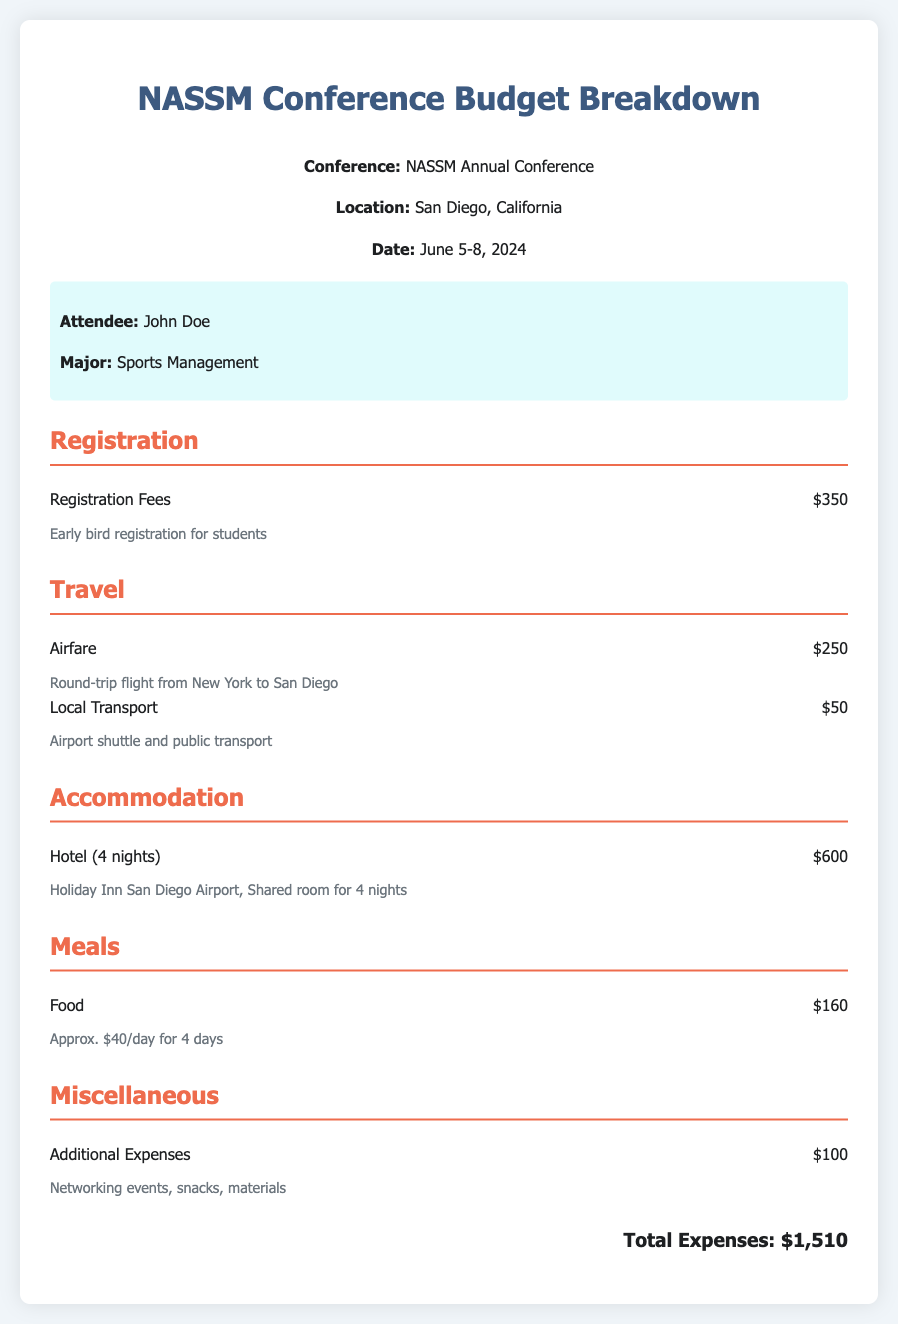What is the conference location? The conference is held in San Diego, California, as stated in the header information.
Answer: San Diego, California What is the registration fee for the conference? The registration fees detailed in the budget section indicate the amount as $350.
Answer: $350 How much is the airfare for the trip? The airfare expense listed in the travel section is $250 for a round-trip flight.
Answer: $250 What is the total expense for accommodation? The budget section for accommodation shows a total of $600 for 4 nights at the hotel.
Answer: $600 How much will meals cost for the duration of the conference? The expense item for food indicates the cost is $160, approximated at $40 per day for 4 days.
Answer: $160 What is the total amount listed for miscellaneous expenses? The budget section covers additional expenses showing a total of $100 under miscellaneous.
Answer: $100 What is the total estimated expense for attending the conference? The total expenses are summed up at the end of the document, showing $1,510.
Answer: $1,510 How many nights will the attendee stay at the hotel? The document specifies a hotel stay of 4 nights during the conference.
Answer: 4 nights What is the major of the attendee? The attendee information section mentions that the major is Sports Management.
Answer: Sports Management 